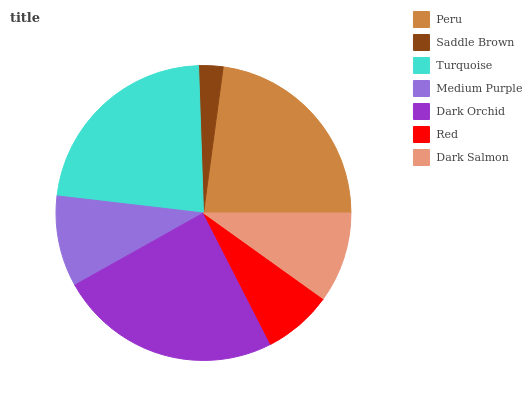Is Saddle Brown the minimum?
Answer yes or no. Yes. Is Dark Orchid the maximum?
Answer yes or no. Yes. Is Turquoise the minimum?
Answer yes or no. No. Is Turquoise the maximum?
Answer yes or no. No. Is Turquoise greater than Saddle Brown?
Answer yes or no. Yes. Is Saddle Brown less than Turquoise?
Answer yes or no. Yes. Is Saddle Brown greater than Turquoise?
Answer yes or no. No. Is Turquoise less than Saddle Brown?
Answer yes or no. No. Is Medium Purple the high median?
Answer yes or no. Yes. Is Medium Purple the low median?
Answer yes or no. Yes. Is Peru the high median?
Answer yes or no. No. Is Red the low median?
Answer yes or no. No. 